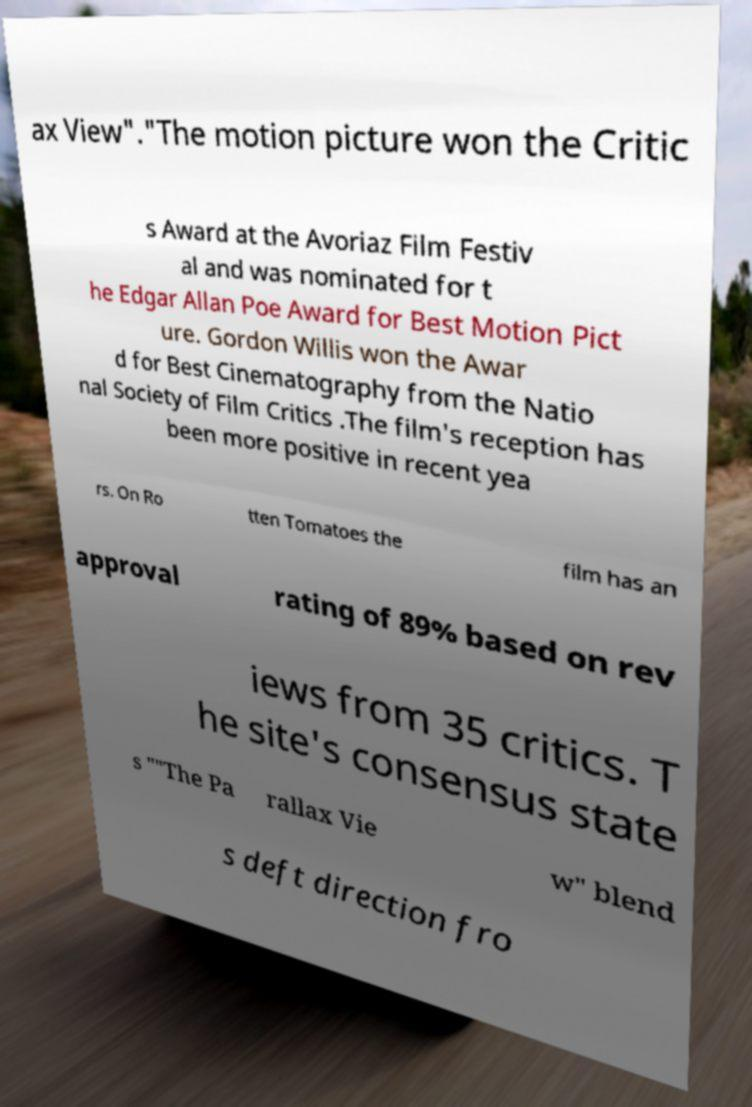Please identify and transcribe the text found in this image. ax View"."The motion picture won the Critic s Award at the Avoriaz Film Festiv al and was nominated for t he Edgar Allan Poe Award for Best Motion Pict ure. Gordon Willis won the Awar d for Best Cinematography from the Natio nal Society of Film Critics .The film's reception has been more positive in recent yea rs. On Ro tten Tomatoes the film has an approval rating of 89% based on rev iews from 35 critics. T he site's consensus state s ""The Pa rallax Vie w" blend s deft direction fro 